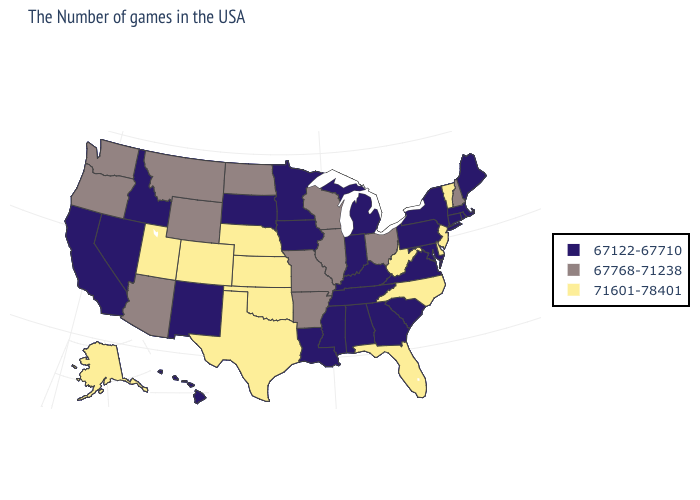Does the first symbol in the legend represent the smallest category?
Write a very short answer. Yes. Does Oregon have a lower value than Delaware?
Answer briefly. Yes. What is the lowest value in the MidWest?
Write a very short answer. 67122-67710. Name the states that have a value in the range 67768-71238?
Be succinct. New Hampshire, Ohio, Wisconsin, Illinois, Missouri, Arkansas, North Dakota, Wyoming, Montana, Arizona, Washington, Oregon. Does Vermont have a lower value than South Carolina?
Concise answer only. No. Among the states that border Michigan , does Indiana have the highest value?
Keep it brief. No. Name the states that have a value in the range 71601-78401?
Be succinct. Vermont, New Jersey, Delaware, North Carolina, West Virginia, Florida, Kansas, Nebraska, Oklahoma, Texas, Colorado, Utah, Alaska. Does Utah have the lowest value in the USA?
Quick response, please. No. Is the legend a continuous bar?
Give a very brief answer. No. Name the states that have a value in the range 67768-71238?
Concise answer only. New Hampshire, Ohio, Wisconsin, Illinois, Missouri, Arkansas, North Dakota, Wyoming, Montana, Arizona, Washington, Oregon. What is the value of Oklahoma?
Write a very short answer. 71601-78401. Name the states that have a value in the range 71601-78401?
Answer briefly. Vermont, New Jersey, Delaware, North Carolina, West Virginia, Florida, Kansas, Nebraska, Oklahoma, Texas, Colorado, Utah, Alaska. What is the lowest value in the USA?
Short answer required. 67122-67710. What is the lowest value in states that border Maine?
Write a very short answer. 67768-71238. 